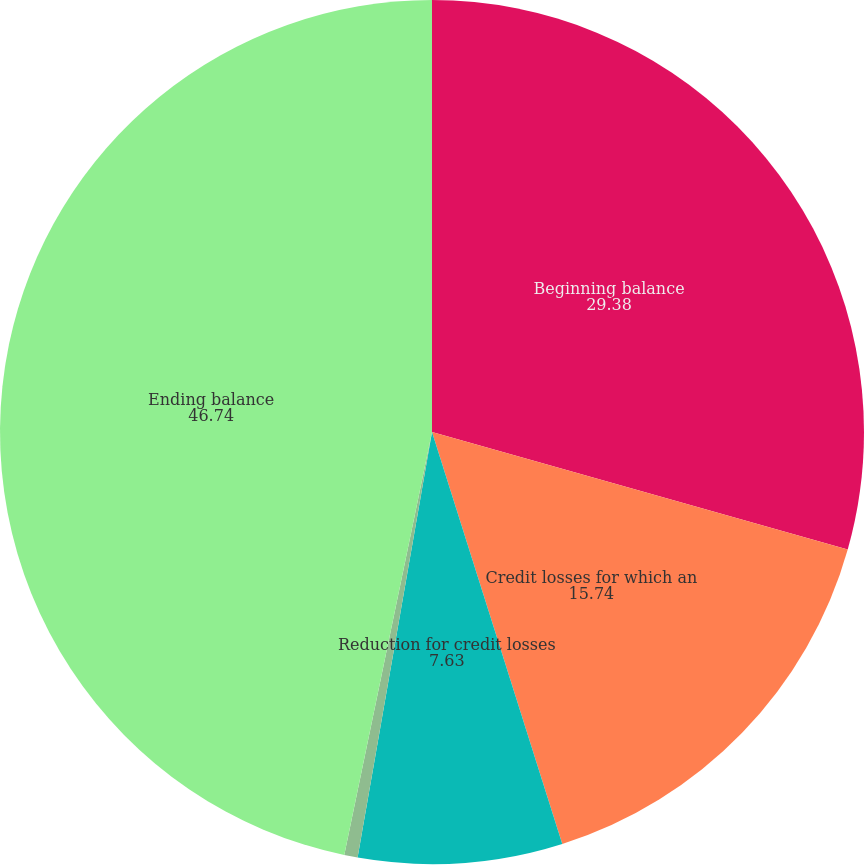Convert chart. <chart><loc_0><loc_0><loc_500><loc_500><pie_chart><fcel>Beginning balance<fcel>Credit losses for which an<fcel>Reduction for credit losses<fcel>Net reduction (increase) for<fcel>Ending balance<nl><fcel>29.38%<fcel>15.74%<fcel>7.63%<fcel>0.5%<fcel>46.74%<nl></chart> 